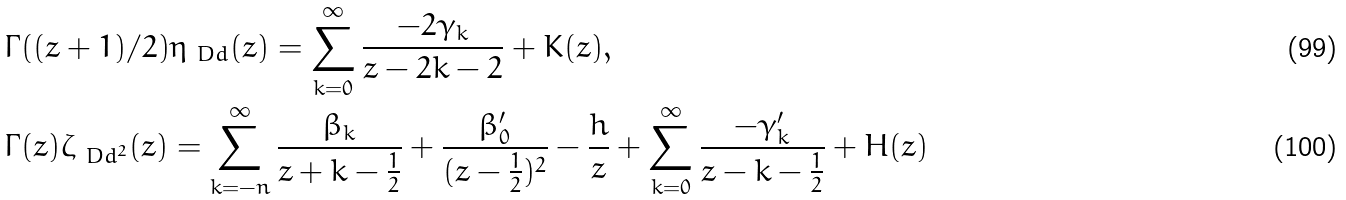Convert formula to latex. <formula><loc_0><loc_0><loc_500><loc_500>& \Gamma ( ( z + 1 ) / 2 ) \eta _ { \ D d } ( z ) = \sum ^ { \infty } _ { k = 0 } \frac { - 2 \gamma _ { k } } { z - 2 k - 2 } + K ( z ) , \\ & \Gamma ( z ) \zeta _ { \ D d ^ { 2 } } ( z ) = \sum ^ { \infty } _ { k = - n } \frac { \beta _ { k } } { z + k - \frac { 1 } { 2 } } + \frac { \beta ^ { \prime } _ { 0 } } { ( z - \frac { 1 } { 2 } ) ^ { 2 } } - \frac { h } { z } + \sum ^ { \infty } _ { k = 0 } \frac { - \gamma ^ { \prime } _ { k } } { z - k - \frac { 1 } { 2 } } + H ( z )</formula> 